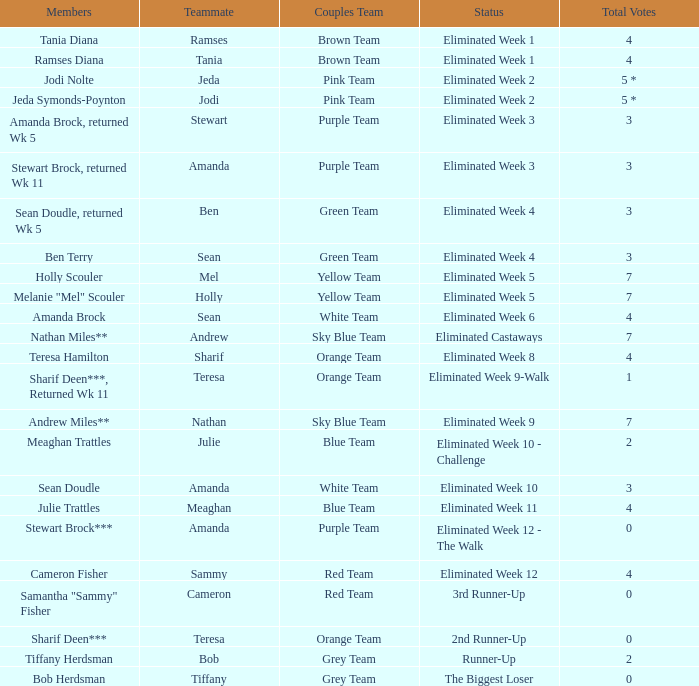What were Holly Scouler's total votes? 7.0. 